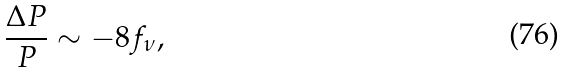Convert formula to latex. <formula><loc_0><loc_0><loc_500><loc_500>\frac { \Delta P } { P } \sim - 8 f _ { \nu } ,</formula> 